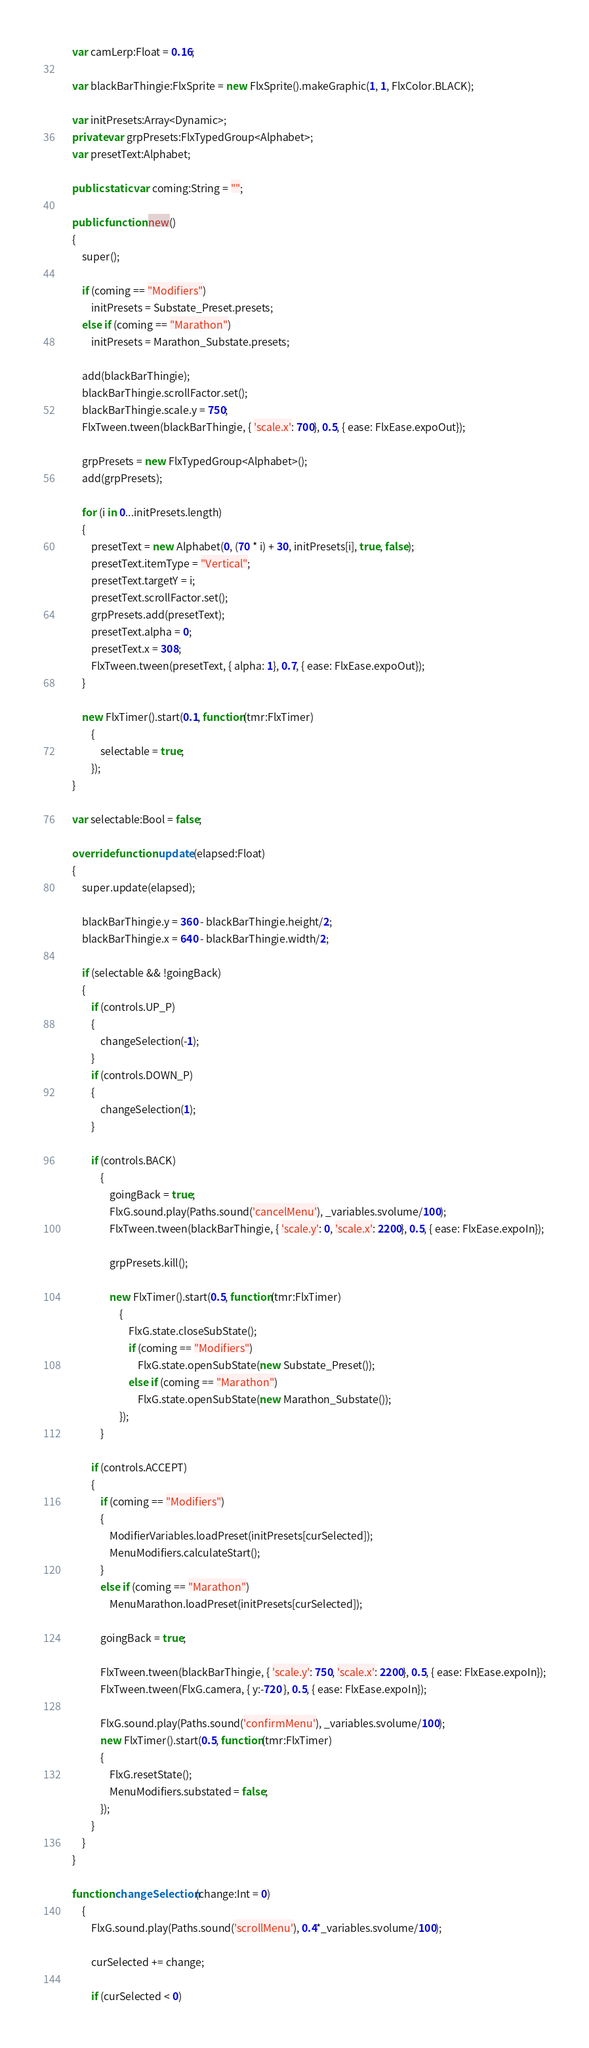Convert code to text. <code><loc_0><loc_0><loc_500><loc_500><_Haxe_>
    var camLerp:Float = 0.16;

    var blackBarThingie:FlxSprite = new FlxSprite().makeGraphic(1, 1, FlxColor.BLACK);

    var initPresets:Array<Dynamic>;
    private var grpPresets:FlxTypedGroup<Alphabet>;
    var presetText:Alphabet;

    public static var coming:String = "";

    public function new()
    {
        super();

        if (coming == "Modifiers")
            initPresets = Substate_Preset.presets;
        else if (coming == "Marathon")
            initPresets = Marathon_Substate.presets;

		add(blackBarThingie);
        blackBarThingie.scrollFactor.set();
        blackBarThingie.scale.y = 750;
        FlxTween.tween(blackBarThingie, { 'scale.x': 700}, 0.5, { ease: FlxEase.expoOut});

        grpPresets = new FlxTypedGroup<Alphabet>();
		add(grpPresets);

		for (i in 0...initPresets.length)
		{
			presetText = new Alphabet(0, (70 * i) + 30, initPresets[i], true, false);
			presetText.itemType = "Vertical";
			presetText.targetY = i;
            presetText.scrollFactor.set();
			grpPresets.add(presetText);
            presetText.alpha = 0;
            presetText.x = 308;
            FlxTween.tween(presetText, { alpha: 1}, 0.7, { ease: FlxEase.expoOut});
		}

        new FlxTimer().start(0.1, function(tmr:FlxTimer)
			{
				selectable = true;
			});
    }

    var selectable:Bool = false;

    override function update(elapsed:Float)
    {
        super.update(elapsed);

        blackBarThingie.y = 360 - blackBarThingie.height/2;
        blackBarThingie.x = 640 - blackBarThingie.width/2;

        if (selectable && !goingBack)
        {
            if (controls.UP_P)
            {
                changeSelection(-1);
            }
            if (controls.DOWN_P)
            {
                changeSelection(1);
            }

            if (controls.BACK)
                {
                    goingBack = true;
                    FlxG.sound.play(Paths.sound('cancelMenu'), _variables.svolume/100);
                    FlxTween.tween(blackBarThingie, { 'scale.y': 0, 'scale.x': 2200}, 0.5, { ease: FlxEase.expoIn});

                    grpPresets.kill();

                    new FlxTimer().start(0.5, function(tmr:FlxTimer)
                        {
                            FlxG.state.closeSubState();
                            if (coming == "Modifiers")
                                FlxG.state.openSubState(new Substate_Preset());
                            else if (coming == "Marathon")
                                FlxG.state.openSubState(new Marathon_Substate());
                        });
                }
        
            if (controls.ACCEPT)
            {
                if (coming == "Modifiers")
                {
                    ModifierVariables.loadPreset(initPresets[curSelected]);
                    MenuModifiers.calculateStart();
                }
                else if (coming == "Marathon")
                    MenuMarathon.loadPreset(initPresets[curSelected]);

                goingBack = true;
                        
                FlxTween.tween(blackBarThingie, { 'scale.y': 750, 'scale.x': 2200}, 0.5, { ease: FlxEase.expoIn});
                FlxTween.tween(FlxG.camera, { y:-720 }, 0.5, { ease: FlxEase.expoIn});

                FlxG.sound.play(Paths.sound('confirmMenu'), _variables.svolume/100);
                new FlxTimer().start(0.5, function(tmr:FlxTimer)
                {
                    FlxG.resetState();
                    MenuModifiers.substated = false;
                });
            }
        }
    }

    function changeSelection(change:Int = 0)
        {
            FlxG.sound.play(Paths.sound('scrollMenu'), 0.4*_variables.svolume/100);
    
            curSelected += change;
    
            if (curSelected < 0)</code> 